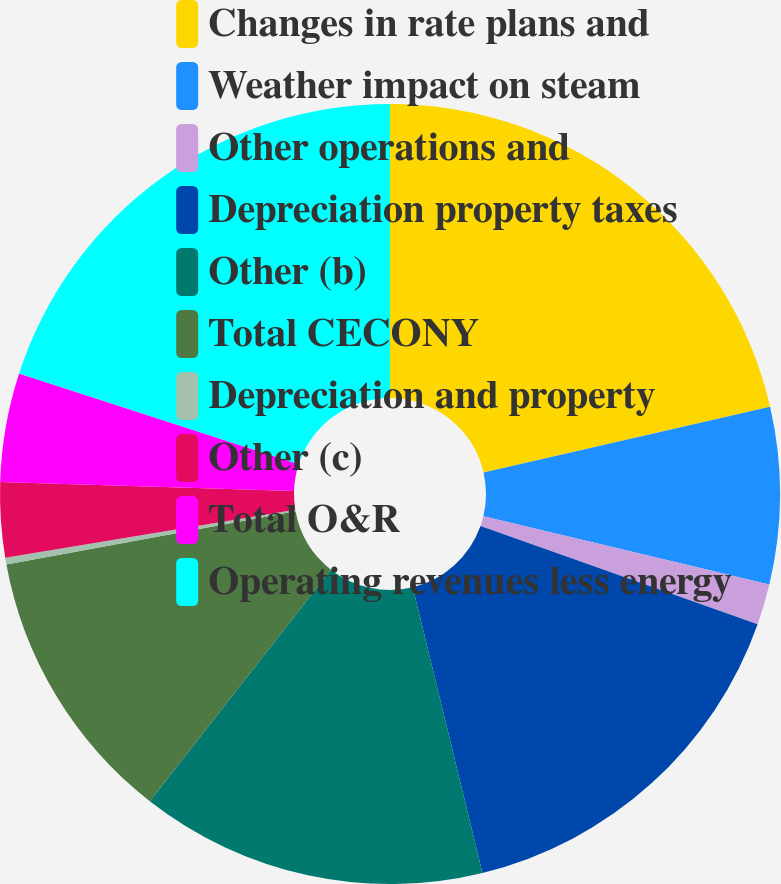Convert chart to OTSL. <chart><loc_0><loc_0><loc_500><loc_500><pie_chart><fcel>Changes in rate plans and<fcel>Weather impact on steam<fcel>Other operations and<fcel>Depreciation property taxes<fcel>Other (b)<fcel>Total CECONY<fcel>Depreciation and property<fcel>Other (c)<fcel>Total O&R<fcel>Operating revenues less energy<nl><fcel>21.41%<fcel>7.32%<fcel>1.69%<fcel>15.77%<fcel>14.37%<fcel>11.55%<fcel>0.28%<fcel>3.1%<fcel>4.51%<fcel>20.0%<nl></chart> 